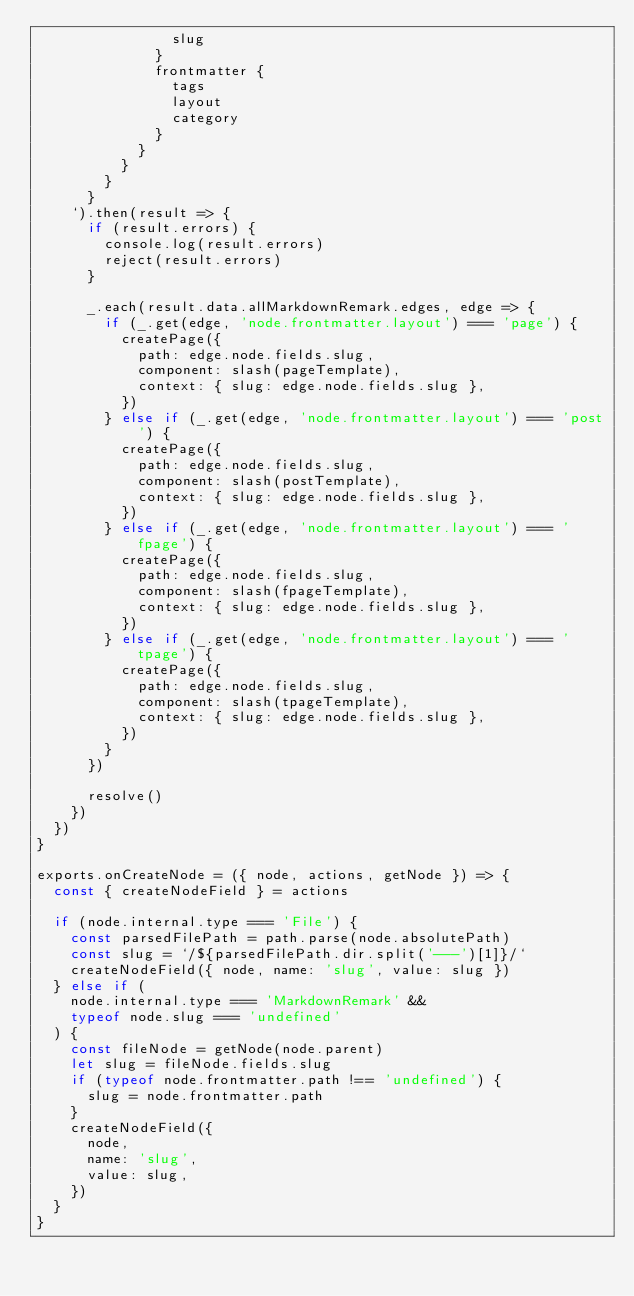Convert code to text. <code><loc_0><loc_0><loc_500><loc_500><_JavaScript_>                slug
              }
              frontmatter {
                tags
                layout
                category
              }
            }
          }
        }
      }
    `).then(result => {
      if (result.errors) {
        console.log(result.errors)
        reject(result.errors)
      }

      _.each(result.data.allMarkdownRemark.edges, edge => {
        if (_.get(edge, 'node.frontmatter.layout') === 'page') {
          createPage({
            path: edge.node.fields.slug,
            component: slash(pageTemplate),
            context: { slug: edge.node.fields.slug },
          })
        } else if (_.get(edge, 'node.frontmatter.layout') === 'post') {
          createPage({
            path: edge.node.fields.slug,
            component: slash(postTemplate),
            context: { slug: edge.node.fields.slug },
          })
        } else if (_.get(edge, 'node.frontmatter.layout') === 'fpage') {
          createPage({
            path: edge.node.fields.slug,
            component: slash(fpageTemplate),
            context: { slug: edge.node.fields.slug },
          })
        } else if (_.get(edge, 'node.frontmatter.layout') === 'tpage') {
          createPage({
            path: edge.node.fields.slug,
            component: slash(tpageTemplate),
            context: { slug: edge.node.fields.slug },
          })
        }
      })

      resolve()
    })
  })
}

exports.onCreateNode = ({ node, actions, getNode }) => {
  const { createNodeField } = actions

  if (node.internal.type === 'File') {
    const parsedFilePath = path.parse(node.absolutePath)
    const slug = `/${parsedFilePath.dir.split('---')[1]}/`
    createNodeField({ node, name: 'slug', value: slug })
  } else if (
    node.internal.type === 'MarkdownRemark' &&
    typeof node.slug === 'undefined'
  ) {
    const fileNode = getNode(node.parent)
    let slug = fileNode.fields.slug
    if (typeof node.frontmatter.path !== 'undefined') {
      slug = node.frontmatter.path
    }
    createNodeField({
      node,
      name: 'slug',
      value: slug,
    })
  }
}
</code> 